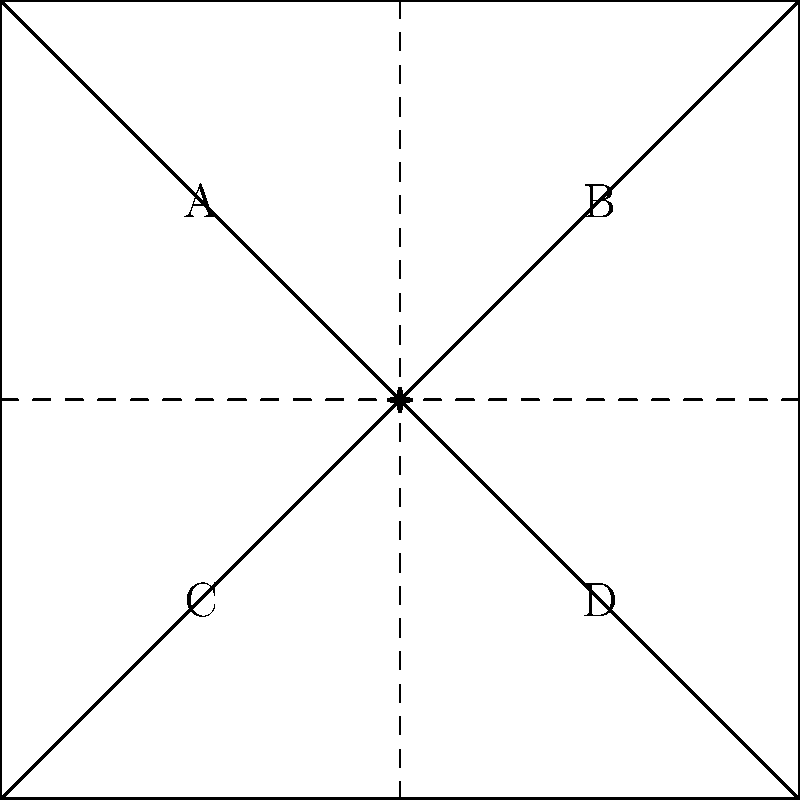A pamphlet for an interfaith social justice campaign is designed as a square that will be folded twice along the dotted lines to create a smaller square. The letters A, B, C, and D represent different sections of content. When the pamphlet is completely folded, which section will be on the outside, visible to the reader? To solve this problem, we need to mentally fold the pamphlet according to the given instructions:

1. The square is divided into four equal sections, labeled A, B, C, and D.
2. The first fold is along the vertical dotted line, which will bring the right half over the left half.
3. After this first fold, sections B and D will be on top of A and C, respectively.
4. The second fold is along the horizontal dotted line, which will bring the top half down over the bottom half.
5. After this second fold, the order of sections from top to bottom will be:
   - D (now on top)
   - B (folded under D)
   - C (folded under B)
   - A (at the bottom)

6. Therefore, when the pamphlet is completely folded, section D will be on the outside and visible to the reader.

This mental folding exercise is relevant to the sociologist persona as it demonstrates how information in interfaith social justice campaigns can be structured and presented to maximize impact and readability.
Answer: D 